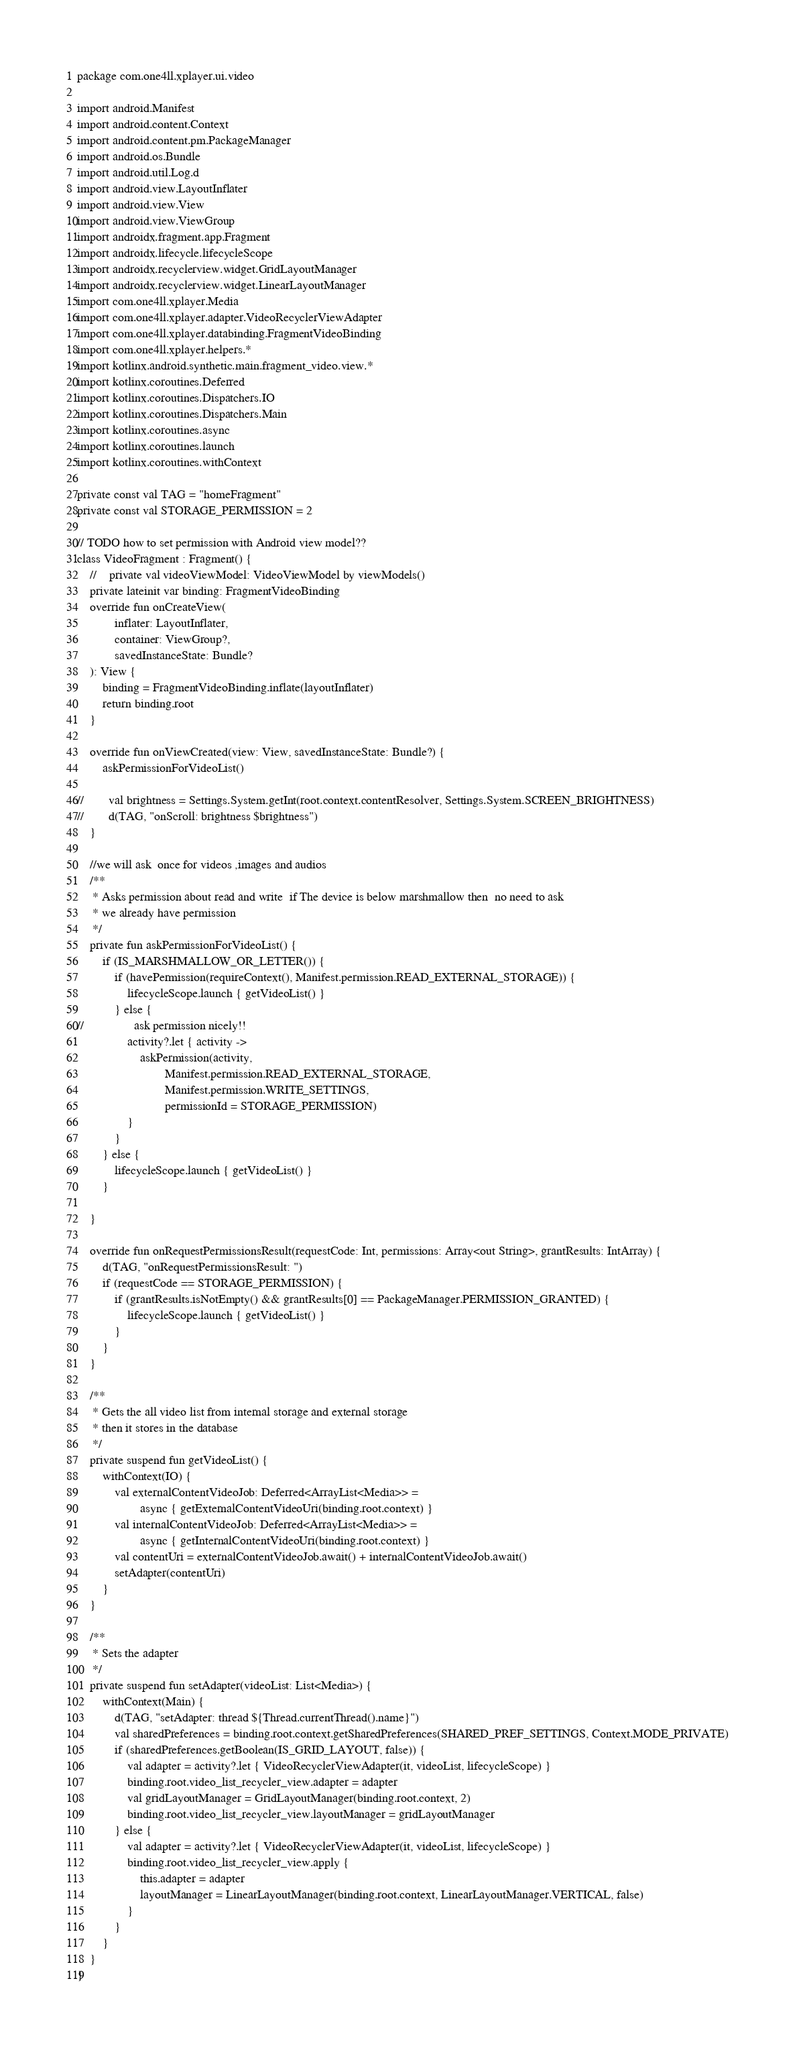<code> <loc_0><loc_0><loc_500><loc_500><_Kotlin_>package com.one4ll.xplayer.ui.video

import android.Manifest
import android.content.Context
import android.content.pm.PackageManager
import android.os.Bundle
import android.util.Log.d
import android.view.LayoutInflater
import android.view.View
import android.view.ViewGroup
import androidx.fragment.app.Fragment
import androidx.lifecycle.lifecycleScope
import androidx.recyclerview.widget.GridLayoutManager
import androidx.recyclerview.widget.LinearLayoutManager
import com.one4ll.xplayer.Media
import com.one4ll.xplayer.adapter.VideoRecyclerViewAdapter
import com.one4ll.xplayer.databinding.FragmentVideoBinding
import com.one4ll.xplayer.helpers.*
import kotlinx.android.synthetic.main.fragment_video.view.*
import kotlinx.coroutines.Deferred
import kotlinx.coroutines.Dispatchers.IO
import kotlinx.coroutines.Dispatchers.Main
import kotlinx.coroutines.async
import kotlinx.coroutines.launch
import kotlinx.coroutines.withContext

private const val TAG = "homeFragment"
private const val STORAGE_PERMISSION = 2

// TODO how to set permission with Android view model??
class VideoFragment : Fragment() {
    //    private val videoViewModel: VideoViewModel by viewModels()
    private lateinit var binding: FragmentVideoBinding
    override fun onCreateView(
            inflater: LayoutInflater,
            container: ViewGroup?,
            savedInstanceState: Bundle?
    ): View {
        binding = FragmentVideoBinding.inflate(layoutInflater)
        return binding.root
    }

    override fun onViewCreated(view: View, savedInstanceState: Bundle?) {
        askPermissionForVideoList()

//        val brightness = Settings.System.getInt(root.context.contentResolver, Settings.System.SCREEN_BRIGHTNESS)
//        d(TAG, "onScroll: brightness $brightness")
    }

    //we will ask  once for videos ,images and audios
    /**
     * Asks permission about read and write  if The device is below marshmallow then  no need to ask
     * we already have permission
     */
    private fun askPermissionForVideoList() {
        if (IS_MARSHMALLOW_OR_LETTER()) {
            if (havePermission(requireContext(), Manifest.permission.READ_EXTERNAL_STORAGE)) {
                lifecycleScope.launch { getVideoList() }
            } else {
//                ask permission nicely!!
                activity?.let { activity ->
                    askPermission(activity,
                            Manifest.permission.READ_EXTERNAL_STORAGE,
                            Manifest.permission.WRITE_SETTINGS,
                            permissionId = STORAGE_PERMISSION)
                }
            }
        } else {
            lifecycleScope.launch { getVideoList() }
        }

    }

    override fun onRequestPermissionsResult(requestCode: Int, permissions: Array<out String>, grantResults: IntArray) {
        d(TAG, "onRequestPermissionsResult: ")
        if (requestCode == STORAGE_PERMISSION) {
            if (grantResults.isNotEmpty() && grantResults[0] == PackageManager.PERMISSION_GRANTED) {
                lifecycleScope.launch { getVideoList() }
            }
        }
    }

    /**
     * Gets the all video list from internal storage and external storage
     * then it stores in the database
     */
    private suspend fun getVideoList() {
        withContext(IO) {
            val externalContentVideoJob: Deferred<ArrayList<Media>> =
                    async { getExternalContentVideoUri(binding.root.context) }
            val internalContentVideoJob: Deferred<ArrayList<Media>> =
                    async { getInternalContentVideoUri(binding.root.context) }
            val contentUri = externalContentVideoJob.await() + internalContentVideoJob.await()
            setAdapter(contentUri)
        }
    }

    /**
     * Sets the adapter
     */
    private suspend fun setAdapter(videoList: List<Media>) {
        withContext(Main) {
            d(TAG, "setAdapter: thread ${Thread.currentThread().name}")
            val sharedPreferences = binding.root.context.getSharedPreferences(SHARED_PREF_SETTINGS, Context.MODE_PRIVATE)
            if (sharedPreferences.getBoolean(IS_GRID_LAYOUT, false)) {
                val adapter = activity?.let { VideoRecyclerViewAdapter(it, videoList, lifecycleScope) }
                binding.root.video_list_recycler_view.adapter = adapter
                val gridLayoutManager = GridLayoutManager(binding.root.context, 2)
                binding.root.video_list_recycler_view.layoutManager = gridLayoutManager
            } else {
                val adapter = activity?.let { VideoRecyclerViewAdapter(it, videoList, lifecycleScope) }
                binding.root.video_list_recycler_view.apply {
                    this.adapter = adapter
                    layoutManager = LinearLayoutManager(binding.root.context, LinearLayoutManager.VERTICAL, false)
                }
            }
        }
    }
}
</code> 